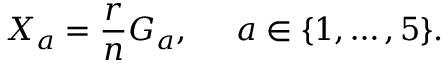<formula> <loc_0><loc_0><loc_500><loc_500>X _ { a } = \frac { r } { n } G _ { a } , \, a \in \{ 1 , \dots , 5 \} .</formula> 